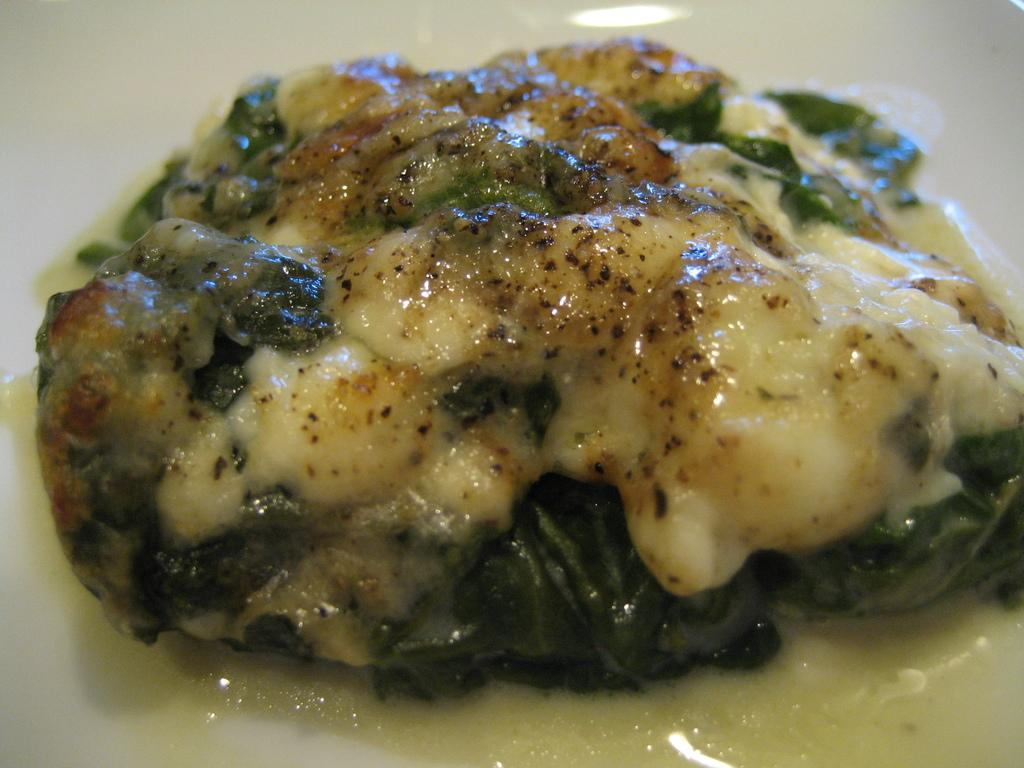What can be seen in the image? There is food in the image. What type of carpenter is visible in the image? There is no carpenter present in the image; it only features food. What kind of robin can be seen in the image? There is no robin present in the image; it only features food. 